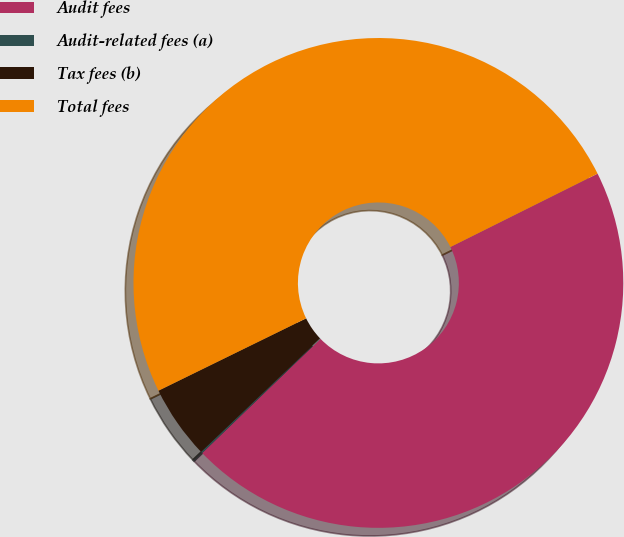<chart> <loc_0><loc_0><loc_500><loc_500><pie_chart><fcel>Audit fees<fcel>Audit-related fees (a)<fcel>Tax fees (b)<fcel>Total fees<nl><fcel>45.14%<fcel>0.11%<fcel>4.86%<fcel>49.89%<nl></chart> 